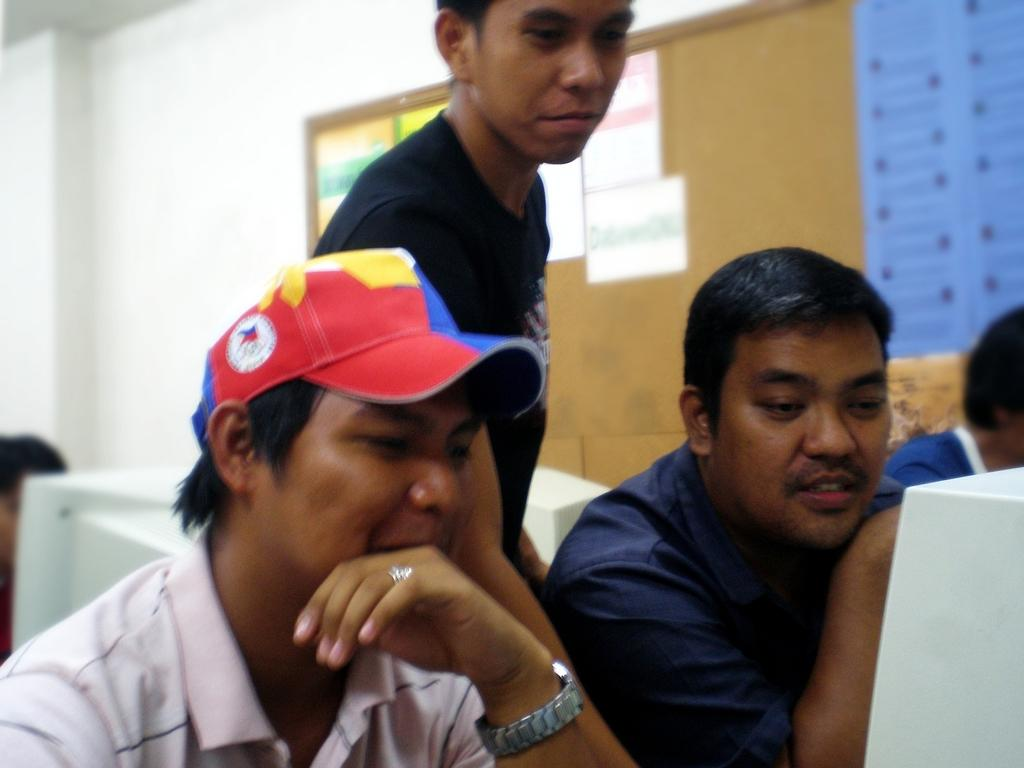How many people are visible in the image? There are four people visible in the image. What are the people doing in the image? Three persons are sitting, and one person is standing behind them. What can be seen in the right corner of the image? There is a board in the right corner of the image. What is attached to the board? Papers are attached to the board. What time is displayed on the clock in the image? There is no clock present in the image. Can you describe the color of the tongue of the person standing in the image? There is no tongue visible in the image, as the people are fully clothed. 